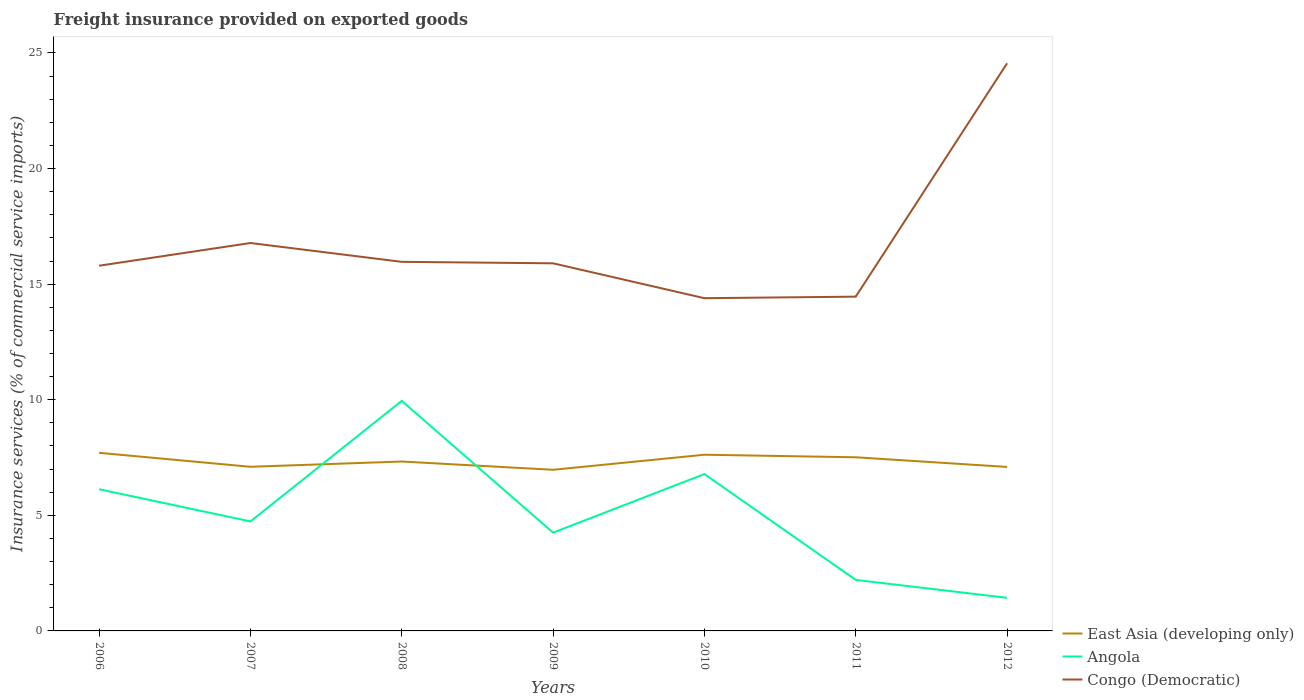How many different coloured lines are there?
Ensure brevity in your answer.  3. Across all years, what is the maximum freight insurance provided on exported goods in East Asia (developing only)?
Make the answer very short. 6.97. What is the total freight insurance provided on exported goods in Angola in the graph?
Offer a terse response. 7.75. What is the difference between the highest and the second highest freight insurance provided on exported goods in Congo (Democratic)?
Make the answer very short. 10.16. What is the difference between the highest and the lowest freight insurance provided on exported goods in East Asia (developing only)?
Keep it short and to the point. 3. Is the freight insurance provided on exported goods in Angola strictly greater than the freight insurance provided on exported goods in Congo (Democratic) over the years?
Give a very brief answer. Yes. How many lines are there?
Your answer should be compact. 3. What is the difference between two consecutive major ticks on the Y-axis?
Your answer should be very brief. 5. Does the graph contain any zero values?
Offer a very short reply. No. How many legend labels are there?
Your answer should be compact. 3. What is the title of the graph?
Make the answer very short. Freight insurance provided on exported goods. Does "Pakistan" appear as one of the legend labels in the graph?
Give a very brief answer. No. What is the label or title of the Y-axis?
Provide a short and direct response. Insurance services (% of commercial service imports). What is the Insurance services (% of commercial service imports) of East Asia (developing only) in 2006?
Provide a succinct answer. 7.7. What is the Insurance services (% of commercial service imports) in Angola in 2006?
Give a very brief answer. 6.13. What is the Insurance services (% of commercial service imports) of Congo (Democratic) in 2006?
Your response must be concise. 15.8. What is the Insurance services (% of commercial service imports) in East Asia (developing only) in 2007?
Provide a short and direct response. 7.1. What is the Insurance services (% of commercial service imports) in Angola in 2007?
Offer a terse response. 4.74. What is the Insurance services (% of commercial service imports) of Congo (Democratic) in 2007?
Your response must be concise. 16.78. What is the Insurance services (% of commercial service imports) of East Asia (developing only) in 2008?
Your response must be concise. 7.33. What is the Insurance services (% of commercial service imports) of Angola in 2008?
Make the answer very short. 9.95. What is the Insurance services (% of commercial service imports) in Congo (Democratic) in 2008?
Your response must be concise. 15.97. What is the Insurance services (% of commercial service imports) of East Asia (developing only) in 2009?
Ensure brevity in your answer.  6.97. What is the Insurance services (% of commercial service imports) in Angola in 2009?
Give a very brief answer. 4.25. What is the Insurance services (% of commercial service imports) in Congo (Democratic) in 2009?
Offer a very short reply. 15.9. What is the Insurance services (% of commercial service imports) in East Asia (developing only) in 2010?
Your answer should be compact. 7.62. What is the Insurance services (% of commercial service imports) in Angola in 2010?
Keep it short and to the point. 6.79. What is the Insurance services (% of commercial service imports) of Congo (Democratic) in 2010?
Provide a short and direct response. 14.39. What is the Insurance services (% of commercial service imports) of East Asia (developing only) in 2011?
Ensure brevity in your answer.  7.51. What is the Insurance services (% of commercial service imports) of Angola in 2011?
Make the answer very short. 2.21. What is the Insurance services (% of commercial service imports) in Congo (Democratic) in 2011?
Your answer should be compact. 14.46. What is the Insurance services (% of commercial service imports) in East Asia (developing only) in 2012?
Your response must be concise. 7.09. What is the Insurance services (% of commercial service imports) in Angola in 2012?
Offer a very short reply. 1.43. What is the Insurance services (% of commercial service imports) of Congo (Democratic) in 2012?
Give a very brief answer. 24.55. Across all years, what is the maximum Insurance services (% of commercial service imports) of East Asia (developing only)?
Provide a succinct answer. 7.7. Across all years, what is the maximum Insurance services (% of commercial service imports) in Angola?
Offer a very short reply. 9.95. Across all years, what is the maximum Insurance services (% of commercial service imports) of Congo (Democratic)?
Your answer should be compact. 24.55. Across all years, what is the minimum Insurance services (% of commercial service imports) in East Asia (developing only)?
Your answer should be very brief. 6.97. Across all years, what is the minimum Insurance services (% of commercial service imports) of Angola?
Your answer should be very brief. 1.43. Across all years, what is the minimum Insurance services (% of commercial service imports) of Congo (Democratic)?
Offer a terse response. 14.39. What is the total Insurance services (% of commercial service imports) in East Asia (developing only) in the graph?
Your response must be concise. 51.33. What is the total Insurance services (% of commercial service imports) of Angola in the graph?
Your answer should be very brief. 35.49. What is the total Insurance services (% of commercial service imports) in Congo (Democratic) in the graph?
Provide a short and direct response. 117.85. What is the difference between the Insurance services (% of commercial service imports) in East Asia (developing only) in 2006 and that in 2007?
Your answer should be very brief. 0.6. What is the difference between the Insurance services (% of commercial service imports) of Angola in 2006 and that in 2007?
Provide a succinct answer. 1.39. What is the difference between the Insurance services (% of commercial service imports) of Congo (Democratic) in 2006 and that in 2007?
Ensure brevity in your answer.  -0.98. What is the difference between the Insurance services (% of commercial service imports) of East Asia (developing only) in 2006 and that in 2008?
Provide a succinct answer. 0.38. What is the difference between the Insurance services (% of commercial service imports) in Angola in 2006 and that in 2008?
Your answer should be very brief. -3.82. What is the difference between the Insurance services (% of commercial service imports) in Congo (Democratic) in 2006 and that in 2008?
Provide a succinct answer. -0.17. What is the difference between the Insurance services (% of commercial service imports) of East Asia (developing only) in 2006 and that in 2009?
Keep it short and to the point. 0.73. What is the difference between the Insurance services (% of commercial service imports) of Angola in 2006 and that in 2009?
Offer a terse response. 1.88. What is the difference between the Insurance services (% of commercial service imports) of Congo (Democratic) in 2006 and that in 2009?
Your answer should be very brief. -0.1. What is the difference between the Insurance services (% of commercial service imports) of East Asia (developing only) in 2006 and that in 2010?
Provide a succinct answer. 0.08. What is the difference between the Insurance services (% of commercial service imports) in Angola in 2006 and that in 2010?
Keep it short and to the point. -0.66. What is the difference between the Insurance services (% of commercial service imports) of Congo (Democratic) in 2006 and that in 2010?
Offer a terse response. 1.41. What is the difference between the Insurance services (% of commercial service imports) of East Asia (developing only) in 2006 and that in 2011?
Give a very brief answer. 0.19. What is the difference between the Insurance services (% of commercial service imports) of Angola in 2006 and that in 2011?
Your response must be concise. 3.92. What is the difference between the Insurance services (% of commercial service imports) in Congo (Democratic) in 2006 and that in 2011?
Provide a succinct answer. 1.34. What is the difference between the Insurance services (% of commercial service imports) in East Asia (developing only) in 2006 and that in 2012?
Give a very brief answer. 0.61. What is the difference between the Insurance services (% of commercial service imports) in Angola in 2006 and that in 2012?
Keep it short and to the point. 4.7. What is the difference between the Insurance services (% of commercial service imports) of Congo (Democratic) in 2006 and that in 2012?
Offer a very short reply. -8.76. What is the difference between the Insurance services (% of commercial service imports) of East Asia (developing only) in 2007 and that in 2008?
Provide a short and direct response. -0.23. What is the difference between the Insurance services (% of commercial service imports) in Angola in 2007 and that in 2008?
Your response must be concise. -5.21. What is the difference between the Insurance services (% of commercial service imports) in Congo (Democratic) in 2007 and that in 2008?
Provide a succinct answer. 0.81. What is the difference between the Insurance services (% of commercial service imports) in East Asia (developing only) in 2007 and that in 2009?
Provide a short and direct response. 0.13. What is the difference between the Insurance services (% of commercial service imports) of Angola in 2007 and that in 2009?
Provide a short and direct response. 0.49. What is the difference between the Insurance services (% of commercial service imports) in Congo (Democratic) in 2007 and that in 2009?
Your answer should be very brief. 0.88. What is the difference between the Insurance services (% of commercial service imports) of East Asia (developing only) in 2007 and that in 2010?
Offer a terse response. -0.52. What is the difference between the Insurance services (% of commercial service imports) of Angola in 2007 and that in 2010?
Give a very brief answer. -2.05. What is the difference between the Insurance services (% of commercial service imports) of Congo (Democratic) in 2007 and that in 2010?
Your response must be concise. 2.39. What is the difference between the Insurance services (% of commercial service imports) of East Asia (developing only) in 2007 and that in 2011?
Provide a short and direct response. -0.41. What is the difference between the Insurance services (% of commercial service imports) in Angola in 2007 and that in 2011?
Provide a short and direct response. 2.53. What is the difference between the Insurance services (% of commercial service imports) in Congo (Democratic) in 2007 and that in 2011?
Provide a short and direct response. 2.32. What is the difference between the Insurance services (% of commercial service imports) of East Asia (developing only) in 2007 and that in 2012?
Provide a short and direct response. 0.01. What is the difference between the Insurance services (% of commercial service imports) of Angola in 2007 and that in 2012?
Provide a short and direct response. 3.31. What is the difference between the Insurance services (% of commercial service imports) of Congo (Democratic) in 2007 and that in 2012?
Provide a short and direct response. -7.77. What is the difference between the Insurance services (% of commercial service imports) in East Asia (developing only) in 2008 and that in 2009?
Keep it short and to the point. 0.36. What is the difference between the Insurance services (% of commercial service imports) of Angola in 2008 and that in 2009?
Make the answer very short. 5.7. What is the difference between the Insurance services (% of commercial service imports) in Congo (Democratic) in 2008 and that in 2009?
Your response must be concise. 0.06. What is the difference between the Insurance services (% of commercial service imports) of East Asia (developing only) in 2008 and that in 2010?
Make the answer very short. -0.29. What is the difference between the Insurance services (% of commercial service imports) in Angola in 2008 and that in 2010?
Ensure brevity in your answer.  3.17. What is the difference between the Insurance services (% of commercial service imports) of Congo (Democratic) in 2008 and that in 2010?
Make the answer very short. 1.57. What is the difference between the Insurance services (% of commercial service imports) in East Asia (developing only) in 2008 and that in 2011?
Provide a succinct answer. -0.18. What is the difference between the Insurance services (% of commercial service imports) in Angola in 2008 and that in 2011?
Your answer should be very brief. 7.75. What is the difference between the Insurance services (% of commercial service imports) in Congo (Democratic) in 2008 and that in 2011?
Give a very brief answer. 1.51. What is the difference between the Insurance services (% of commercial service imports) in East Asia (developing only) in 2008 and that in 2012?
Keep it short and to the point. 0.23. What is the difference between the Insurance services (% of commercial service imports) in Angola in 2008 and that in 2012?
Provide a succinct answer. 8.52. What is the difference between the Insurance services (% of commercial service imports) of Congo (Democratic) in 2008 and that in 2012?
Ensure brevity in your answer.  -8.59. What is the difference between the Insurance services (% of commercial service imports) of East Asia (developing only) in 2009 and that in 2010?
Keep it short and to the point. -0.65. What is the difference between the Insurance services (% of commercial service imports) of Angola in 2009 and that in 2010?
Your answer should be compact. -2.53. What is the difference between the Insurance services (% of commercial service imports) in Congo (Democratic) in 2009 and that in 2010?
Your answer should be compact. 1.51. What is the difference between the Insurance services (% of commercial service imports) of East Asia (developing only) in 2009 and that in 2011?
Your answer should be compact. -0.54. What is the difference between the Insurance services (% of commercial service imports) of Angola in 2009 and that in 2011?
Your response must be concise. 2.04. What is the difference between the Insurance services (% of commercial service imports) in Congo (Democratic) in 2009 and that in 2011?
Your answer should be compact. 1.44. What is the difference between the Insurance services (% of commercial service imports) in East Asia (developing only) in 2009 and that in 2012?
Keep it short and to the point. -0.12. What is the difference between the Insurance services (% of commercial service imports) in Angola in 2009 and that in 2012?
Keep it short and to the point. 2.82. What is the difference between the Insurance services (% of commercial service imports) in Congo (Democratic) in 2009 and that in 2012?
Give a very brief answer. -8.65. What is the difference between the Insurance services (% of commercial service imports) in East Asia (developing only) in 2010 and that in 2011?
Offer a terse response. 0.11. What is the difference between the Insurance services (% of commercial service imports) in Angola in 2010 and that in 2011?
Your answer should be very brief. 4.58. What is the difference between the Insurance services (% of commercial service imports) in Congo (Democratic) in 2010 and that in 2011?
Provide a short and direct response. -0.07. What is the difference between the Insurance services (% of commercial service imports) in East Asia (developing only) in 2010 and that in 2012?
Make the answer very short. 0.53. What is the difference between the Insurance services (% of commercial service imports) of Angola in 2010 and that in 2012?
Keep it short and to the point. 5.35. What is the difference between the Insurance services (% of commercial service imports) of Congo (Democratic) in 2010 and that in 2012?
Provide a short and direct response. -10.16. What is the difference between the Insurance services (% of commercial service imports) of East Asia (developing only) in 2011 and that in 2012?
Offer a terse response. 0.42. What is the difference between the Insurance services (% of commercial service imports) of Angola in 2011 and that in 2012?
Offer a terse response. 0.77. What is the difference between the Insurance services (% of commercial service imports) of Congo (Democratic) in 2011 and that in 2012?
Offer a terse response. -10.09. What is the difference between the Insurance services (% of commercial service imports) in East Asia (developing only) in 2006 and the Insurance services (% of commercial service imports) in Angola in 2007?
Provide a succinct answer. 2.97. What is the difference between the Insurance services (% of commercial service imports) of East Asia (developing only) in 2006 and the Insurance services (% of commercial service imports) of Congo (Democratic) in 2007?
Your response must be concise. -9.08. What is the difference between the Insurance services (% of commercial service imports) in Angola in 2006 and the Insurance services (% of commercial service imports) in Congo (Democratic) in 2007?
Offer a terse response. -10.65. What is the difference between the Insurance services (% of commercial service imports) of East Asia (developing only) in 2006 and the Insurance services (% of commercial service imports) of Angola in 2008?
Your answer should be compact. -2.25. What is the difference between the Insurance services (% of commercial service imports) of East Asia (developing only) in 2006 and the Insurance services (% of commercial service imports) of Congo (Democratic) in 2008?
Make the answer very short. -8.26. What is the difference between the Insurance services (% of commercial service imports) of Angola in 2006 and the Insurance services (% of commercial service imports) of Congo (Democratic) in 2008?
Offer a very short reply. -9.84. What is the difference between the Insurance services (% of commercial service imports) of East Asia (developing only) in 2006 and the Insurance services (% of commercial service imports) of Angola in 2009?
Ensure brevity in your answer.  3.45. What is the difference between the Insurance services (% of commercial service imports) of East Asia (developing only) in 2006 and the Insurance services (% of commercial service imports) of Congo (Democratic) in 2009?
Your answer should be compact. -8.2. What is the difference between the Insurance services (% of commercial service imports) in Angola in 2006 and the Insurance services (% of commercial service imports) in Congo (Democratic) in 2009?
Provide a short and direct response. -9.77. What is the difference between the Insurance services (% of commercial service imports) in East Asia (developing only) in 2006 and the Insurance services (% of commercial service imports) in Angola in 2010?
Your answer should be compact. 0.92. What is the difference between the Insurance services (% of commercial service imports) of East Asia (developing only) in 2006 and the Insurance services (% of commercial service imports) of Congo (Democratic) in 2010?
Give a very brief answer. -6.69. What is the difference between the Insurance services (% of commercial service imports) in Angola in 2006 and the Insurance services (% of commercial service imports) in Congo (Democratic) in 2010?
Your answer should be very brief. -8.26. What is the difference between the Insurance services (% of commercial service imports) in East Asia (developing only) in 2006 and the Insurance services (% of commercial service imports) in Angola in 2011?
Your answer should be compact. 5.5. What is the difference between the Insurance services (% of commercial service imports) of East Asia (developing only) in 2006 and the Insurance services (% of commercial service imports) of Congo (Democratic) in 2011?
Keep it short and to the point. -6.76. What is the difference between the Insurance services (% of commercial service imports) of Angola in 2006 and the Insurance services (% of commercial service imports) of Congo (Democratic) in 2011?
Your answer should be compact. -8.33. What is the difference between the Insurance services (% of commercial service imports) of East Asia (developing only) in 2006 and the Insurance services (% of commercial service imports) of Angola in 2012?
Ensure brevity in your answer.  6.27. What is the difference between the Insurance services (% of commercial service imports) of East Asia (developing only) in 2006 and the Insurance services (% of commercial service imports) of Congo (Democratic) in 2012?
Give a very brief answer. -16.85. What is the difference between the Insurance services (% of commercial service imports) of Angola in 2006 and the Insurance services (% of commercial service imports) of Congo (Democratic) in 2012?
Keep it short and to the point. -18.43. What is the difference between the Insurance services (% of commercial service imports) of East Asia (developing only) in 2007 and the Insurance services (% of commercial service imports) of Angola in 2008?
Offer a very short reply. -2.85. What is the difference between the Insurance services (% of commercial service imports) of East Asia (developing only) in 2007 and the Insurance services (% of commercial service imports) of Congo (Democratic) in 2008?
Make the answer very short. -8.87. What is the difference between the Insurance services (% of commercial service imports) in Angola in 2007 and the Insurance services (% of commercial service imports) in Congo (Democratic) in 2008?
Make the answer very short. -11.23. What is the difference between the Insurance services (% of commercial service imports) of East Asia (developing only) in 2007 and the Insurance services (% of commercial service imports) of Angola in 2009?
Keep it short and to the point. 2.85. What is the difference between the Insurance services (% of commercial service imports) of East Asia (developing only) in 2007 and the Insurance services (% of commercial service imports) of Congo (Democratic) in 2009?
Offer a terse response. -8.8. What is the difference between the Insurance services (% of commercial service imports) of Angola in 2007 and the Insurance services (% of commercial service imports) of Congo (Democratic) in 2009?
Make the answer very short. -11.16. What is the difference between the Insurance services (% of commercial service imports) in East Asia (developing only) in 2007 and the Insurance services (% of commercial service imports) in Angola in 2010?
Make the answer very short. 0.31. What is the difference between the Insurance services (% of commercial service imports) in East Asia (developing only) in 2007 and the Insurance services (% of commercial service imports) in Congo (Democratic) in 2010?
Ensure brevity in your answer.  -7.29. What is the difference between the Insurance services (% of commercial service imports) in Angola in 2007 and the Insurance services (% of commercial service imports) in Congo (Democratic) in 2010?
Give a very brief answer. -9.66. What is the difference between the Insurance services (% of commercial service imports) of East Asia (developing only) in 2007 and the Insurance services (% of commercial service imports) of Angola in 2011?
Offer a terse response. 4.89. What is the difference between the Insurance services (% of commercial service imports) in East Asia (developing only) in 2007 and the Insurance services (% of commercial service imports) in Congo (Democratic) in 2011?
Your answer should be very brief. -7.36. What is the difference between the Insurance services (% of commercial service imports) of Angola in 2007 and the Insurance services (% of commercial service imports) of Congo (Democratic) in 2011?
Provide a short and direct response. -9.72. What is the difference between the Insurance services (% of commercial service imports) of East Asia (developing only) in 2007 and the Insurance services (% of commercial service imports) of Angola in 2012?
Your answer should be very brief. 5.67. What is the difference between the Insurance services (% of commercial service imports) of East Asia (developing only) in 2007 and the Insurance services (% of commercial service imports) of Congo (Democratic) in 2012?
Keep it short and to the point. -17.45. What is the difference between the Insurance services (% of commercial service imports) in Angola in 2007 and the Insurance services (% of commercial service imports) in Congo (Democratic) in 2012?
Ensure brevity in your answer.  -19.82. What is the difference between the Insurance services (% of commercial service imports) of East Asia (developing only) in 2008 and the Insurance services (% of commercial service imports) of Angola in 2009?
Provide a short and direct response. 3.08. What is the difference between the Insurance services (% of commercial service imports) of East Asia (developing only) in 2008 and the Insurance services (% of commercial service imports) of Congo (Democratic) in 2009?
Keep it short and to the point. -8.57. What is the difference between the Insurance services (% of commercial service imports) in Angola in 2008 and the Insurance services (% of commercial service imports) in Congo (Democratic) in 2009?
Keep it short and to the point. -5.95. What is the difference between the Insurance services (% of commercial service imports) in East Asia (developing only) in 2008 and the Insurance services (% of commercial service imports) in Angola in 2010?
Offer a terse response. 0.54. What is the difference between the Insurance services (% of commercial service imports) in East Asia (developing only) in 2008 and the Insurance services (% of commercial service imports) in Congo (Democratic) in 2010?
Your answer should be very brief. -7.07. What is the difference between the Insurance services (% of commercial service imports) of Angola in 2008 and the Insurance services (% of commercial service imports) of Congo (Democratic) in 2010?
Your answer should be very brief. -4.44. What is the difference between the Insurance services (% of commercial service imports) of East Asia (developing only) in 2008 and the Insurance services (% of commercial service imports) of Angola in 2011?
Your response must be concise. 5.12. What is the difference between the Insurance services (% of commercial service imports) of East Asia (developing only) in 2008 and the Insurance services (% of commercial service imports) of Congo (Democratic) in 2011?
Ensure brevity in your answer.  -7.13. What is the difference between the Insurance services (% of commercial service imports) of Angola in 2008 and the Insurance services (% of commercial service imports) of Congo (Democratic) in 2011?
Offer a very short reply. -4.51. What is the difference between the Insurance services (% of commercial service imports) of East Asia (developing only) in 2008 and the Insurance services (% of commercial service imports) of Angola in 2012?
Provide a succinct answer. 5.9. What is the difference between the Insurance services (% of commercial service imports) of East Asia (developing only) in 2008 and the Insurance services (% of commercial service imports) of Congo (Democratic) in 2012?
Your answer should be compact. -17.23. What is the difference between the Insurance services (% of commercial service imports) of Angola in 2008 and the Insurance services (% of commercial service imports) of Congo (Democratic) in 2012?
Give a very brief answer. -14.6. What is the difference between the Insurance services (% of commercial service imports) in East Asia (developing only) in 2009 and the Insurance services (% of commercial service imports) in Angola in 2010?
Provide a succinct answer. 0.18. What is the difference between the Insurance services (% of commercial service imports) in East Asia (developing only) in 2009 and the Insurance services (% of commercial service imports) in Congo (Democratic) in 2010?
Offer a very short reply. -7.42. What is the difference between the Insurance services (% of commercial service imports) in Angola in 2009 and the Insurance services (% of commercial service imports) in Congo (Democratic) in 2010?
Offer a terse response. -10.14. What is the difference between the Insurance services (% of commercial service imports) of East Asia (developing only) in 2009 and the Insurance services (% of commercial service imports) of Angola in 2011?
Make the answer very short. 4.76. What is the difference between the Insurance services (% of commercial service imports) in East Asia (developing only) in 2009 and the Insurance services (% of commercial service imports) in Congo (Democratic) in 2011?
Your answer should be very brief. -7.49. What is the difference between the Insurance services (% of commercial service imports) in Angola in 2009 and the Insurance services (% of commercial service imports) in Congo (Democratic) in 2011?
Keep it short and to the point. -10.21. What is the difference between the Insurance services (% of commercial service imports) in East Asia (developing only) in 2009 and the Insurance services (% of commercial service imports) in Angola in 2012?
Your answer should be very brief. 5.54. What is the difference between the Insurance services (% of commercial service imports) of East Asia (developing only) in 2009 and the Insurance services (% of commercial service imports) of Congo (Democratic) in 2012?
Make the answer very short. -17.58. What is the difference between the Insurance services (% of commercial service imports) in Angola in 2009 and the Insurance services (% of commercial service imports) in Congo (Democratic) in 2012?
Ensure brevity in your answer.  -20.3. What is the difference between the Insurance services (% of commercial service imports) in East Asia (developing only) in 2010 and the Insurance services (% of commercial service imports) in Angola in 2011?
Make the answer very short. 5.42. What is the difference between the Insurance services (% of commercial service imports) in East Asia (developing only) in 2010 and the Insurance services (% of commercial service imports) in Congo (Democratic) in 2011?
Your response must be concise. -6.84. What is the difference between the Insurance services (% of commercial service imports) of Angola in 2010 and the Insurance services (% of commercial service imports) of Congo (Democratic) in 2011?
Offer a very short reply. -7.67. What is the difference between the Insurance services (% of commercial service imports) of East Asia (developing only) in 2010 and the Insurance services (% of commercial service imports) of Angola in 2012?
Your response must be concise. 6.19. What is the difference between the Insurance services (% of commercial service imports) in East Asia (developing only) in 2010 and the Insurance services (% of commercial service imports) in Congo (Democratic) in 2012?
Offer a very short reply. -16.93. What is the difference between the Insurance services (% of commercial service imports) in Angola in 2010 and the Insurance services (% of commercial service imports) in Congo (Democratic) in 2012?
Your answer should be compact. -17.77. What is the difference between the Insurance services (% of commercial service imports) of East Asia (developing only) in 2011 and the Insurance services (% of commercial service imports) of Angola in 2012?
Your answer should be compact. 6.08. What is the difference between the Insurance services (% of commercial service imports) of East Asia (developing only) in 2011 and the Insurance services (% of commercial service imports) of Congo (Democratic) in 2012?
Provide a succinct answer. -17.04. What is the difference between the Insurance services (% of commercial service imports) of Angola in 2011 and the Insurance services (% of commercial service imports) of Congo (Democratic) in 2012?
Offer a terse response. -22.35. What is the average Insurance services (% of commercial service imports) of East Asia (developing only) per year?
Your answer should be very brief. 7.33. What is the average Insurance services (% of commercial service imports) in Angola per year?
Your answer should be very brief. 5.07. What is the average Insurance services (% of commercial service imports) of Congo (Democratic) per year?
Provide a succinct answer. 16.84. In the year 2006, what is the difference between the Insurance services (% of commercial service imports) in East Asia (developing only) and Insurance services (% of commercial service imports) in Angola?
Provide a succinct answer. 1.58. In the year 2006, what is the difference between the Insurance services (% of commercial service imports) in East Asia (developing only) and Insurance services (% of commercial service imports) in Congo (Democratic)?
Make the answer very short. -8.09. In the year 2006, what is the difference between the Insurance services (% of commercial service imports) of Angola and Insurance services (% of commercial service imports) of Congo (Democratic)?
Give a very brief answer. -9.67. In the year 2007, what is the difference between the Insurance services (% of commercial service imports) in East Asia (developing only) and Insurance services (% of commercial service imports) in Angola?
Your response must be concise. 2.36. In the year 2007, what is the difference between the Insurance services (% of commercial service imports) of East Asia (developing only) and Insurance services (% of commercial service imports) of Congo (Democratic)?
Offer a very short reply. -9.68. In the year 2007, what is the difference between the Insurance services (% of commercial service imports) of Angola and Insurance services (% of commercial service imports) of Congo (Democratic)?
Provide a short and direct response. -12.04. In the year 2008, what is the difference between the Insurance services (% of commercial service imports) in East Asia (developing only) and Insurance services (% of commercial service imports) in Angola?
Your answer should be very brief. -2.62. In the year 2008, what is the difference between the Insurance services (% of commercial service imports) of East Asia (developing only) and Insurance services (% of commercial service imports) of Congo (Democratic)?
Provide a short and direct response. -8.64. In the year 2008, what is the difference between the Insurance services (% of commercial service imports) in Angola and Insurance services (% of commercial service imports) in Congo (Democratic)?
Provide a short and direct response. -6.01. In the year 2009, what is the difference between the Insurance services (% of commercial service imports) in East Asia (developing only) and Insurance services (% of commercial service imports) in Angola?
Give a very brief answer. 2.72. In the year 2009, what is the difference between the Insurance services (% of commercial service imports) in East Asia (developing only) and Insurance services (% of commercial service imports) in Congo (Democratic)?
Your answer should be very brief. -8.93. In the year 2009, what is the difference between the Insurance services (% of commercial service imports) in Angola and Insurance services (% of commercial service imports) in Congo (Democratic)?
Make the answer very short. -11.65. In the year 2010, what is the difference between the Insurance services (% of commercial service imports) in East Asia (developing only) and Insurance services (% of commercial service imports) in Angola?
Give a very brief answer. 0.84. In the year 2010, what is the difference between the Insurance services (% of commercial service imports) in East Asia (developing only) and Insurance services (% of commercial service imports) in Congo (Democratic)?
Make the answer very short. -6.77. In the year 2010, what is the difference between the Insurance services (% of commercial service imports) in Angola and Insurance services (% of commercial service imports) in Congo (Democratic)?
Your answer should be very brief. -7.61. In the year 2011, what is the difference between the Insurance services (% of commercial service imports) of East Asia (developing only) and Insurance services (% of commercial service imports) of Angola?
Offer a terse response. 5.3. In the year 2011, what is the difference between the Insurance services (% of commercial service imports) of East Asia (developing only) and Insurance services (% of commercial service imports) of Congo (Democratic)?
Your response must be concise. -6.95. In the year 2011, what is the difference between the Insurance services (% of commercial service imports) in Angola and Insurance services (% of commercial service imports) in Congo (Democratic)?
Your response must be concise. -12.25. In the year 2012, what is the difference between the Insurance services (% of commercial service imports) in East Asia (developing only) and Insurance services (% of commercial service imports) in Angola?
Make the answer very short. 5.66. In the year 2012, what is the difference between the Insurance services (% of commercial service imports) of East Asia (developing only) and Insurance services (% of commercial service imports) of Congo (Democratic)?
Your answer should be compact. -17.46. In the year 2012, what is the difference between the Insurance services (% of commercial service imports) of Angola and Insurance services (% of commercial service imports) of Congo (Democratic)?
Your answer should be very brief. -23.12. What is the ratio of the Insurance services (% of commercial service imports) of East Asia (developing only) in 2006 to that in 2007?
Provide a short and direct response. 1.09. What is the ratio of the Insurance services (% of commercial service imports) in Angola in 2006 to that in 2007?
Keep it short and to the point. 1.29. What is the ratio of the Insurance services (% of commercial service imports) of Congo (Democratic) in 2006 to that in 2007?
Offer a terse response. 0.94. What is the ratio of the Insurance services (% of commercial service imports) in East Asia (developing only) in 2006 to that in 2008?
Your answer should be compact. 1.05. What is the ratio of the Insurance services (% of commercial service imports) in Angola in 2006 to that in 2008?
Ensure brevity in your answer.  0.62. What is the ratio of the Insurance services (% of commercial service imports) in East Asia (developing only) in 2006 to that in 2009?
Ensure brevity in your answer.  1.11. What is the ratio of the Insurance services (% of commercial service imports) of Angola in 2006 to that in 2009?
Offer a very short reply. 1.44. What is the ratio of the Insurance services (% of commercial service imports) in East Asia (developing only) in 2006 to that in 2010?
Provide a short and direct response. 1.01. What is the ratio of the Insurance services (% of commercial service imports) in Angola in 2006 to that in 2010?
Your answer should be compact. 0.9. What is the ratio of the Insurance services (% of commercial service imports) in Congo (Democratic) in 2006 to that in 2010?
Keep it short and to the point. 1.1. What is the ratio of the Insurance services (% of commercial service imports) of East Asia (developing only) in 2006 to that in 2011?
Your response must be concise. 1.03. What is the ratio of the Insurance services (% of commercial service imports) of Angola in 2006 to that in 2011?
Keep it short and to the point. 2.78. What is the ratio of the Insurance services (% of commercial service imports) of Congo (Democratic) in 2006 to that in 2011?
Keep it short and to the point. 1.09. What is the ratio of the Insurance services (% of commercial service imports) in East Asia (developing only) in 2006 to that in 2012?
Offer a very short reply. 1.09. What is the ratio of the Insurance services (% of commercial service imports) in Angola in 2006 to that in 2012?
Your answer should be compact. 4.28. What is the ratio of the Insurance services (% of commercial service imports) of Congo (Democratic) in 2006 to that in 2012?
Give a very brief answer. 0.64. What is the ratio of the Insurance services (% of commercial service imports) of East Asia (developing only) in 2007 to that in 2008?
Ensure brevity in your answer.  0.97. What is the ratio of the Insurance services (% of commercial service imports) of Angola in 2007 to that in 2008?
Provide a succinct answer. 0.48. What is the ratio of the Insurance services (% of commercial service imports) in Congo (Democratic) in 2007 to that in 2008?
Give a very brief answer. 1.05. What is the ratio of the Insurance services (% of commercial service imports) in East Asia (developing only) in 2007 to that in 2009?
Make the answer very short. 1.02. What is the ratio of the Insurance services (% of commercial service imports) in Angola in 2007 to that in 2009?
Ensure brevity in your answer.  1.11. What is the ratio of the Insurance services (% of commercial service imports) in Congo (Democratic) in 2007 to that in 2009?
Give a very brief answer. 1.06. What is the ratio of the Insurance services (% of commercial service imports) in East Asia (developing only) in 2007 to that in 2010?
Offer a very short reply. 0.93. What is the ratio of the Insurance services (% of commercial service imports) of Angola in 2007 to that in 2010?
Ensure brevity in your answer.  0.7. What is the ratio of the Insurance services (% of commercial service imports) of Congo (Democratic) in 2007 to that in 2010?
Ensure brevity in your answer.  1.17. What is the ratio of the Insurance services (% of commercial service imports) of East Asia (developing only) in 2007 to that in 2011?
Provide a short and direct response. 0.95. What is the ratio of the Insurance services (% of commercial service imports) in Angola in 2007 to that in 2011?
Provide a short and direct response. 2.15. What is the ratio of the Insurance services (% of commercial service imports) in Congo (Democratic) in 2007 to that in 2011?
Provide a succinct answer. 1.16. What is the ratio of the Insurance services (% of commercial service imports) in Angola in 2007 to that in 2012?
Offer a terse response. 3.31. What is the ratio of the Insurance services (% of commercial service imports) in Congo (Democratic) in 2007 to that in 2012?
Provide a short and direct response. 0.68. What is the ratio of the Insurance services (% of commercial service imports) of East Asia (developing only) in 2008 to that in 2009?
Provide a short and direct response. 1.05. What is the ratio of the Insurance services (% of commercial service imports) in Angola in 2008 to that in 2009?
Provide a short and direct response. 2.34. What is the ratio of the Insurance services (% of commercial service imports) in Congo (Democratic) in 2008 to that in 2009?
Your response must be concise. 1. What is the ratio of the Insurance services (% of commercial service imports) of East Asia (developing only) in 2008 to that in 2010?
Provide a succinct answer. 0.96. What is the ratio of the Insurance services (% of commercial service imports) of Angola in 2008 to that in 2010?
Offer a terse response. 1.47. What is the ratio of the Insurance services (% of commercial service imports) of Congo (Democratic) in 2008 to that in 2010?
Your answer should be compact. 1.11. What is the ratio of the Insurance services (% of commercial service imports) in East Asia (developing only) in 2008 to that in 2011?
Offer a terse response. 0.98. What is the ratio of the Insurance services (% of commercial service imports) of Angola in 2008 to that in 2011?
Make the answer very short. 4.51. What is the ratio of the Insurance services (% of commercial service imports) of Congo (Democratic) in 2008 to that in 2011?
Offer a terse response. 1.1. What is the ratio of the Insurance services (% of commercial service imports) in East Asia (developing only) in 2008 to that in 2012?
Offer a very short reply. 1.03. What is the ratio of the Insurance services (% of commercial service imports) of Angola in 2008 to that in 2012?
Your answer should be compact. 6.95. What is the ratio of the Insurance services (% of commercial service imports) in Congo (Democratic) in 2008 to that in 2012?
Offer a terse response. 0.65. What is the ratio of the Insurance services (% of commercial service imports) of East Asia (developing only) in 2009 to that in 2010?
Provide a succinct answer. 0.91. What is the ratio of the Insurance services (% of commercial service imports) of Angola in 2009 to that in 2010?
Your answer should be compact. 0.63. What is the ratio of the Insurance services (% of commercial service imports) of Congo (Democratic) in 2009 to that in 2010?
Provide a short and direct response. 1.1. What is the ratio of the Insurance services (% of commercial service imports) of East Asia (developing only) in 2009 to that in 2011?
Keep it short and to the point. 0.93. What is the ratio of the Insurance services (% of commercial service imports) of Angola in 2009 to that in 2011?
Your answer should be very brief. 1.93. What is the ratio of the Insurance services (% of commercial service imports) of Congo (Democratic) in 2009 to that in 2011?
Provide a short and direct response. 1.1. What is the ratio of the Insurance services (% of commercial service imports) of East Asia (developing only) in 2009 to that in 2012?
Keep it short and to the point. 0.98. What is the ratio of the Insurance services (% of commercial service imports) of Angola in 2009 to that in 2012?
Offer a very short reply. 2.97. What is the ratio of the Insurance services (% of commercial service imports) of Congo (Democratic) in 2009 to that in 2012?
Give a very brief answer. 0.65. What is the ratio of the Insurance services (% of commercial service imports) of East Asia (developing only) in 2010 to that in 2011?
Ensure brevity in your answer.  1.01. What is the ratio of the Insurance services (% of commercial service imports) of Angola in 2010 to that in 2011?
Your answer should be compact. 3.08. What is the ratio of the Insurance services (% of commercial service imports) of East Asia (developing only) in 2010 to that in 2012?
Provide a short and direct response. 1.07. What is the ratio of the Insurance services (% of commercial service imports) in Angola in 2010 to that in 2012?
Your response must be concise. 4.74. What is the ratio of the Insurance services (% of commercial service imports) in Congo (Democratic) in 2010 to that in 2012?
Offer a terse response. 0.59. What is the ratio of the Insurance services (% of commercial service imports) of East Asia (developing only) in 2011 to that in 2012?
Give a very brief answer. 1.06. What is the ratio of the Insurance services (% of commercial service imports) in Angola in 2011 to that in 2012?
Ensure brevity in your answer.  1.54. What is the ratio of the Insurance services (% of commercial service imports) of Congo (Democratic) in 2011 to that in 2012?
Your answer should be compact. 0.59. What is the difference between the highest and the second highest Insurance services (% of commercial service imports) in East Asia (developing only)?
Your answer should be compact. 0.08. What is the difference between the highest and the second highest Insurance services (% of commercial service imports) in Angola?
Give a very brief answer. 3.17. What is the difference between the highest and the second highest Insurance services (% of commercial service imports) of Congo (Democratic)?
Give a very brief answer. 7.77. What is the difference between the highest and the lowest Insurance services (% of commercial service imports) of East Asia (developing only)?
Provide a short and direct response. 0.73. What is the difference between the highest and the lowest Insurance services (% of commercial service imports) of Angola?
Provide a short and direct response. 8.52. What is the difference between the highest and the lowest Insurance services (% of commercial service imports) of Congo (Democratic)?
Your answer should be very brief. 10.16. 